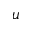<formula> <loc_0><loc_0><loc_500><loc_500>u</formula> 